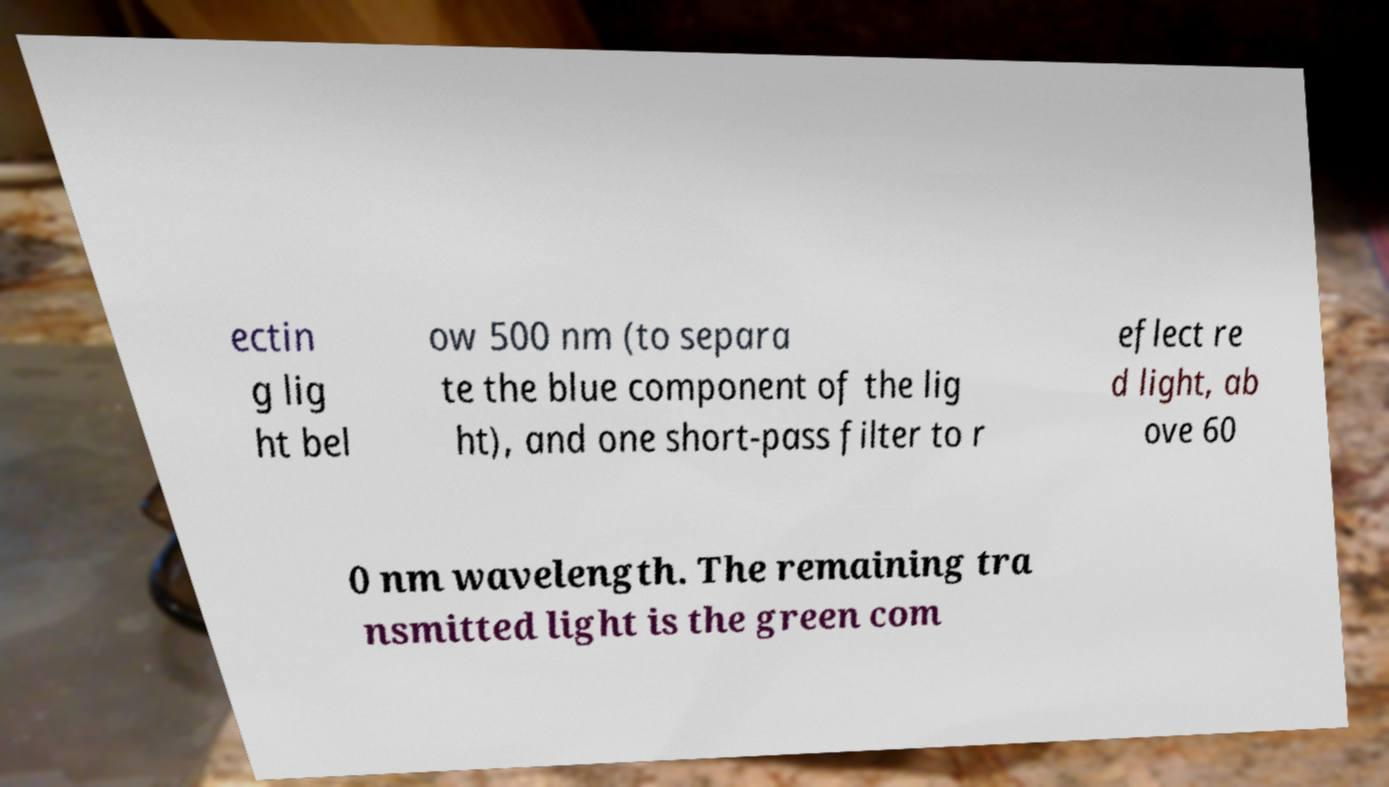Can you accurately transcribe the text from the provided image for me? ectin g lig ht bel ow 500 nm (to separa te the blue component of the lig ht), and one short-pass filter to r eflect re d light, ab ove 60 0 nm wavelength. The remaining tra nsmitted light is the green com 